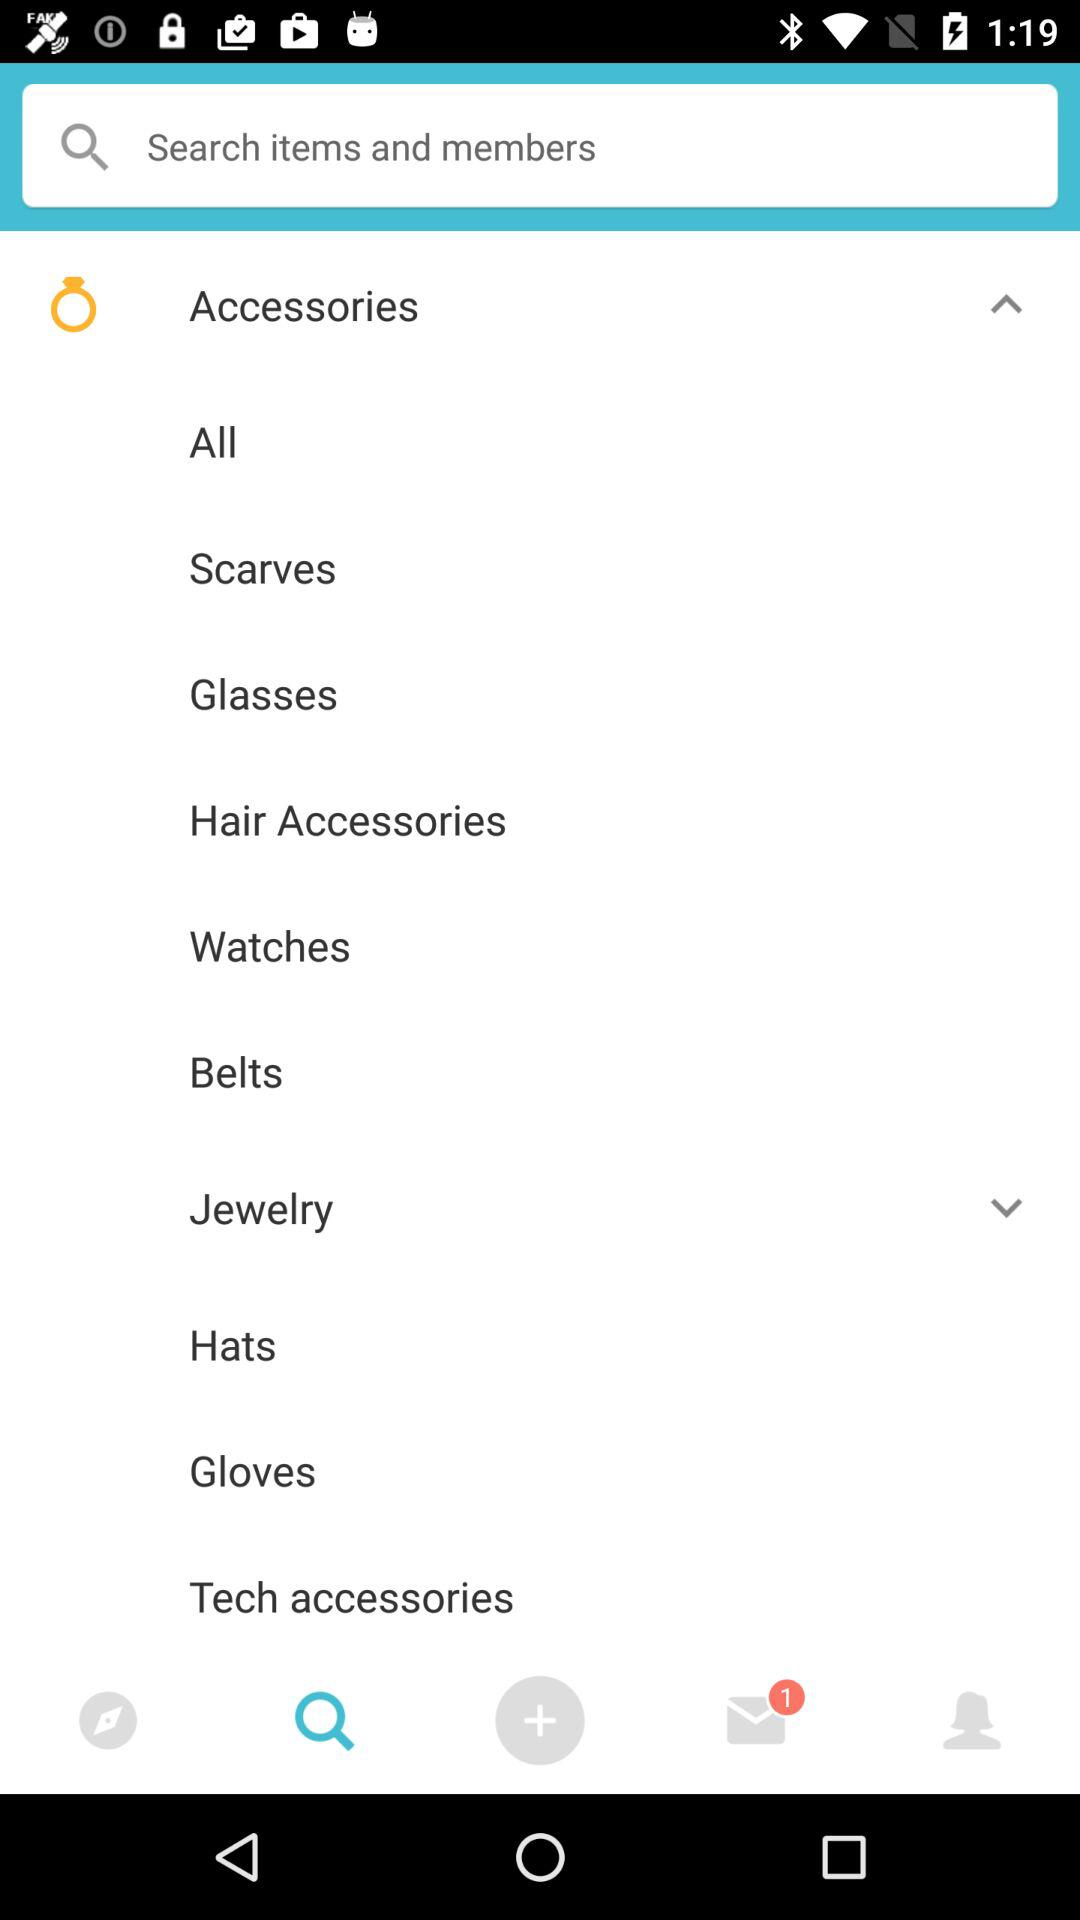Which items are sub-listed in "Jewelry"?
When the provided information is insufficient, respond with <no answer>. <no answer> 